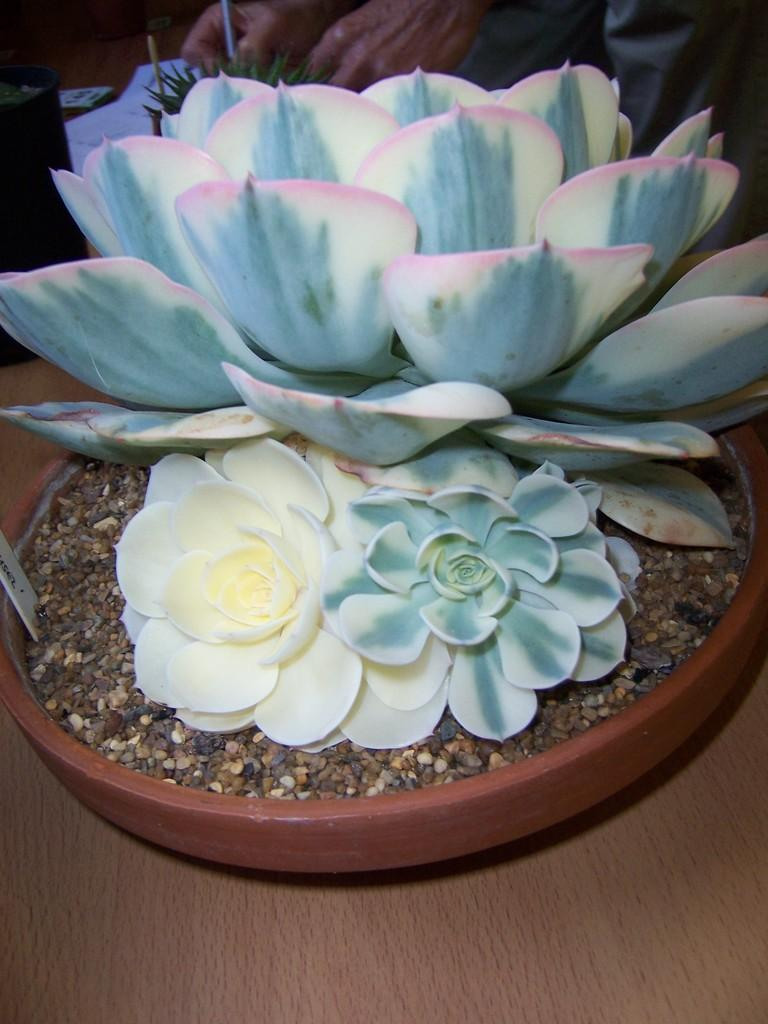What type of plants are in the image? There are flowers in the image. Where are the flowers located? The flowers are in a flower pot. What is present at the bottom of the flower pot? There is soil in the flower pot. On what surface is the flower pot placed? The flower pot is on a table. Who or what else can be seen in the image? There is a person visible in the image. What other plant is present in the image? There is a plant in the image. What non-living object is in the image? There is a paper in the image. What object has a black color in the image? There is a black color object in the image. Can you see any mountains in the image? There are no mountains visible in the image. What type of alley is present in the image? There is no alley present in the image. 